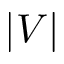Convert formula to latex. <formula><loc_0><loc_0><loc_500><loc_500>| V |</formula> 